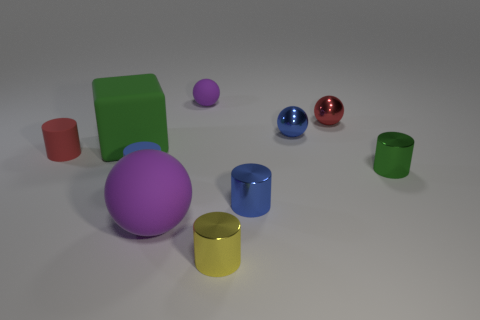What is the shape of the purple thing that is in front of the blue metal object that is in front of the green metallic object?
Keep it short and to the point. Sphere. What is the color of the other metallic object that is the same shape as the red metal object?
Provide a short and direct response. Blue. There is a purple sphere in front of the green cylinder; is its size the same as the green matte cube?
Give a very brief answer. Yes. The metal thing that is the same color as the large block is what shape?
Make the answer very short. Cylinder. What number of other yellow objects are the same material as the tiny yellow object?
Your answer should be very brief. 0. There is a red object to the right of the red thing left of the tiny blue metal object that is in front of the small green thing; what is its material?
Ensure brevity in your answer.  Metal. What is the color of the tiny sphere to the left of the cylinder in front of the blue shiny cylinder?
Give a very brief answer. Purple. There is a object that is the same size as the block; what is its color?
Your answer should be compact. Purple. What number of small objects are either yellow metal cylinders or green rubber balls?
Provide a succinct answer. 1. Is the number of red rubber things that are behind the green metallic thing greater than the number of purple things that are behind the small blue ball?
Ensure brevity in your answer.  No. 